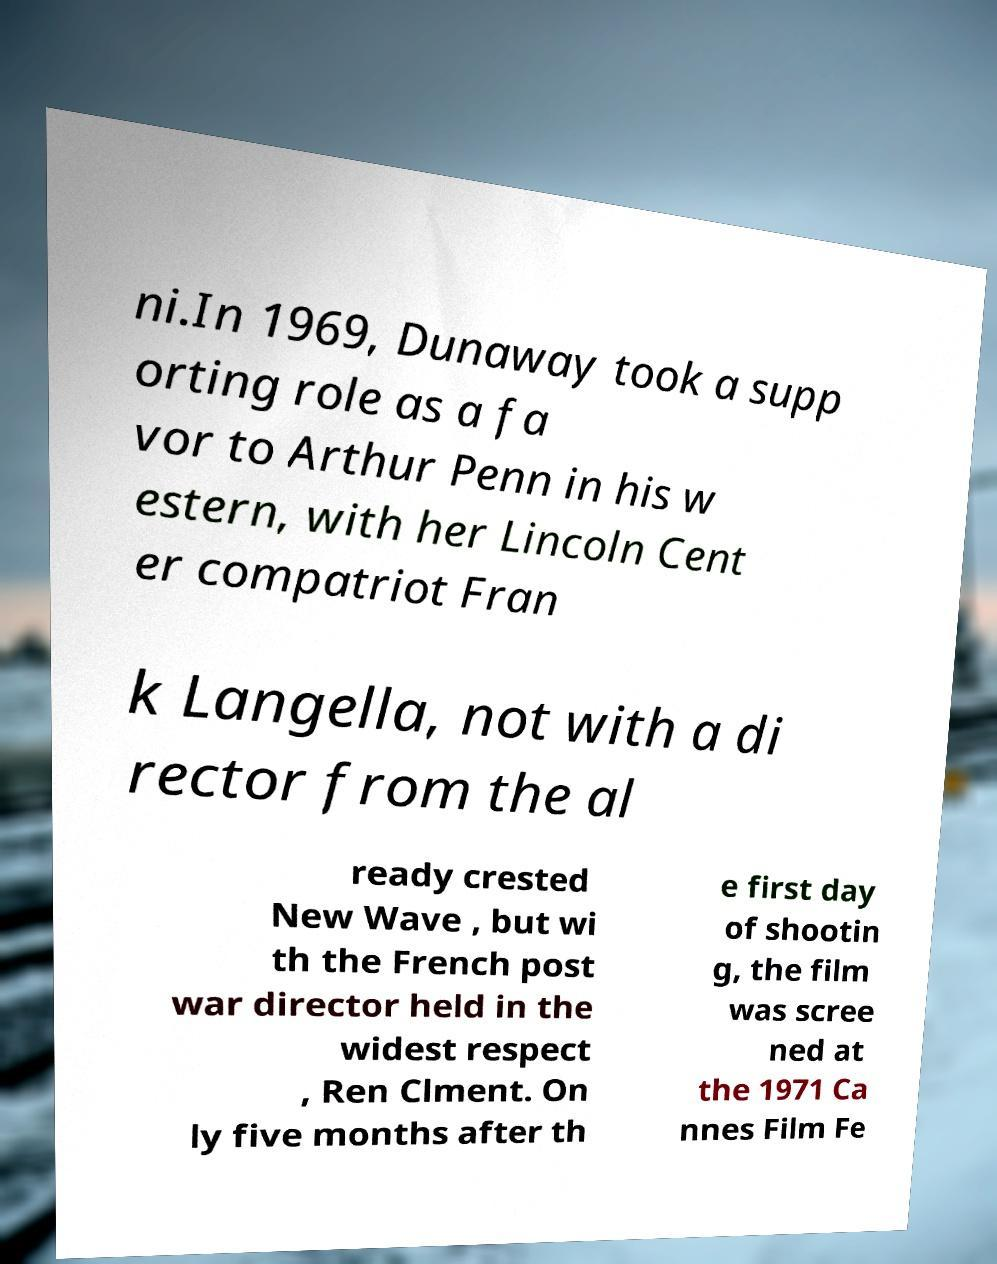Could you assist in decoding the text presented in this image and type it out clearly? ni.In 1969, Dunaway took a supp orting role as a fa vor to Arthur Penn in his w estern, with her Lincoln Cent er compatriot Fran k Langella, not with a di rector from the al ready crested New Wave , but wi th the French post war director held in the widest respect , Ren Clment. On ly five months after th e first day of shootin g, the film was scree ned at the 1971 Ca nnes Film Fe 